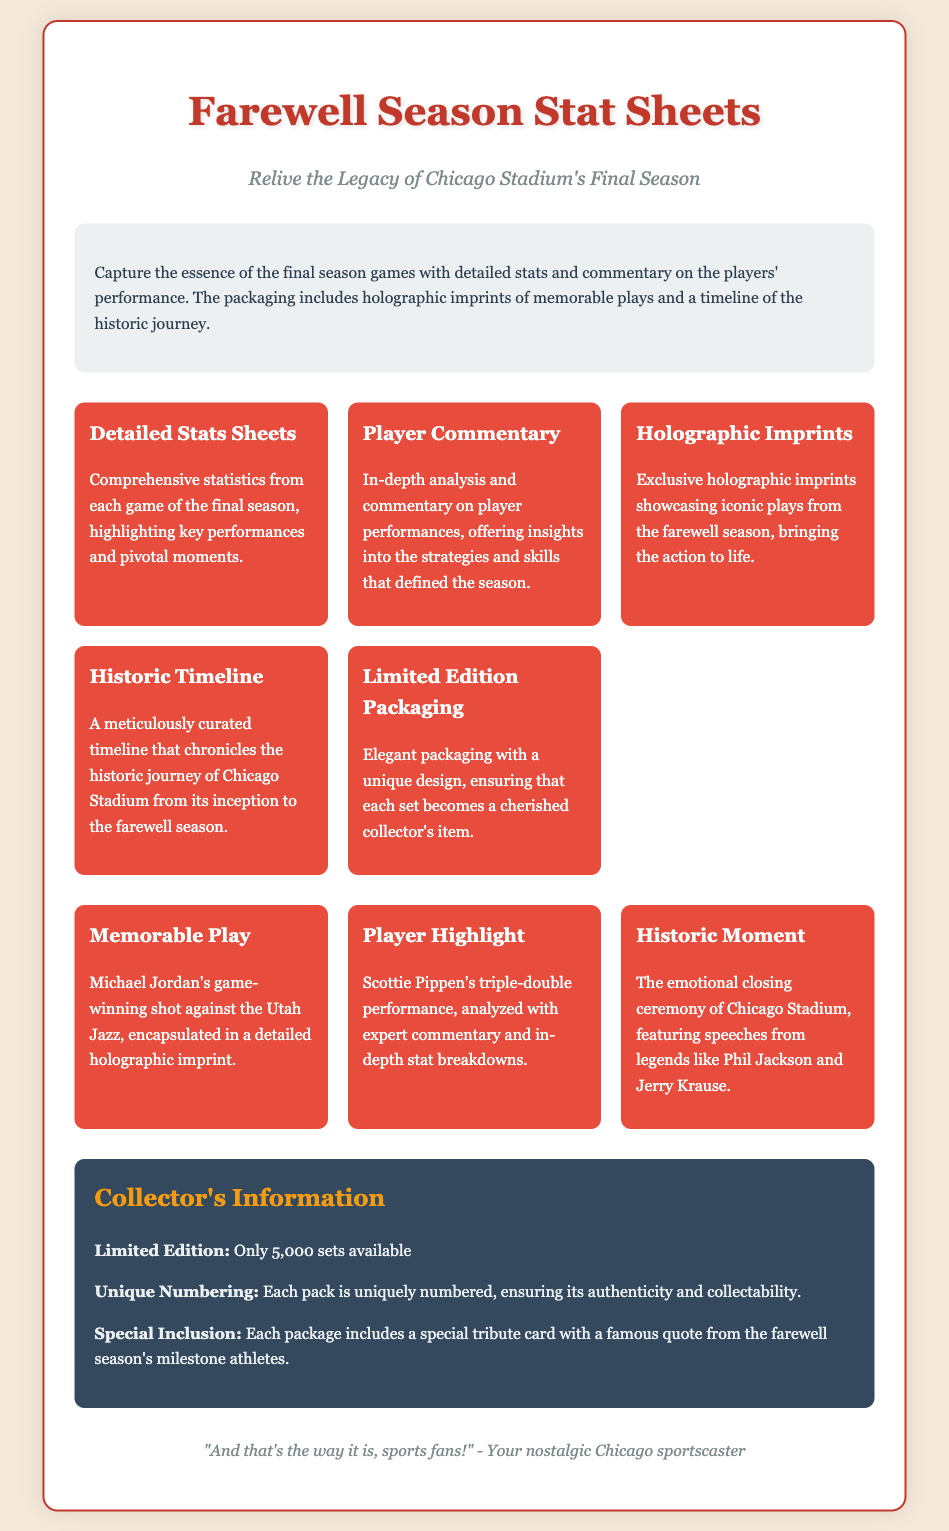What is the title of the product? The title of the product is indicated prominently at the top of the document.
Answer: Farewell Season Stat Sheets What is the tagline of the product? The tagline beneath the title reflects the core theme of the product.
Answer: Relive the Legacy of Chicago Stadium's Final Season How many limited edition sets are available? The document specifies the total number of limited edition sets.
Answer: 5,000 sets What unique feature showcases iconic plays? The document mentions a specific feature that highlights notable moments from the season.
Answer: Holographic Imprints Who made a game-winning shot against the Utah Jazz? The document identifies the player associated with a memorable play mentioned.
Answer: Michael Jordan What type of analysis is provided for player performances? The document describes the kind of insights offered in relation to players' games.
Answer: In-depth analysis What is included in each package that relates to athletes? The document specifies a special item within the packaging aimed at honoring players.
Answer: Tribute card What color scheme is used for the container's text? The document describes the general aesthetic choices for the text used.
Answer: #2c3e50 What is the overarching theme of this product packaging? The document conveys a specific feeling and nostalgia connected with the content.
Answer: Farewell season 